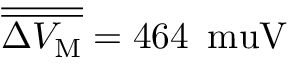Convert formula to latex. <formula><loc_0><loc_0><loc_500><loc_500>\overline { { \overline { { \Delta V _ { \mathrm M } } } } } = 4 6 4 \, \ m u V</formula> 